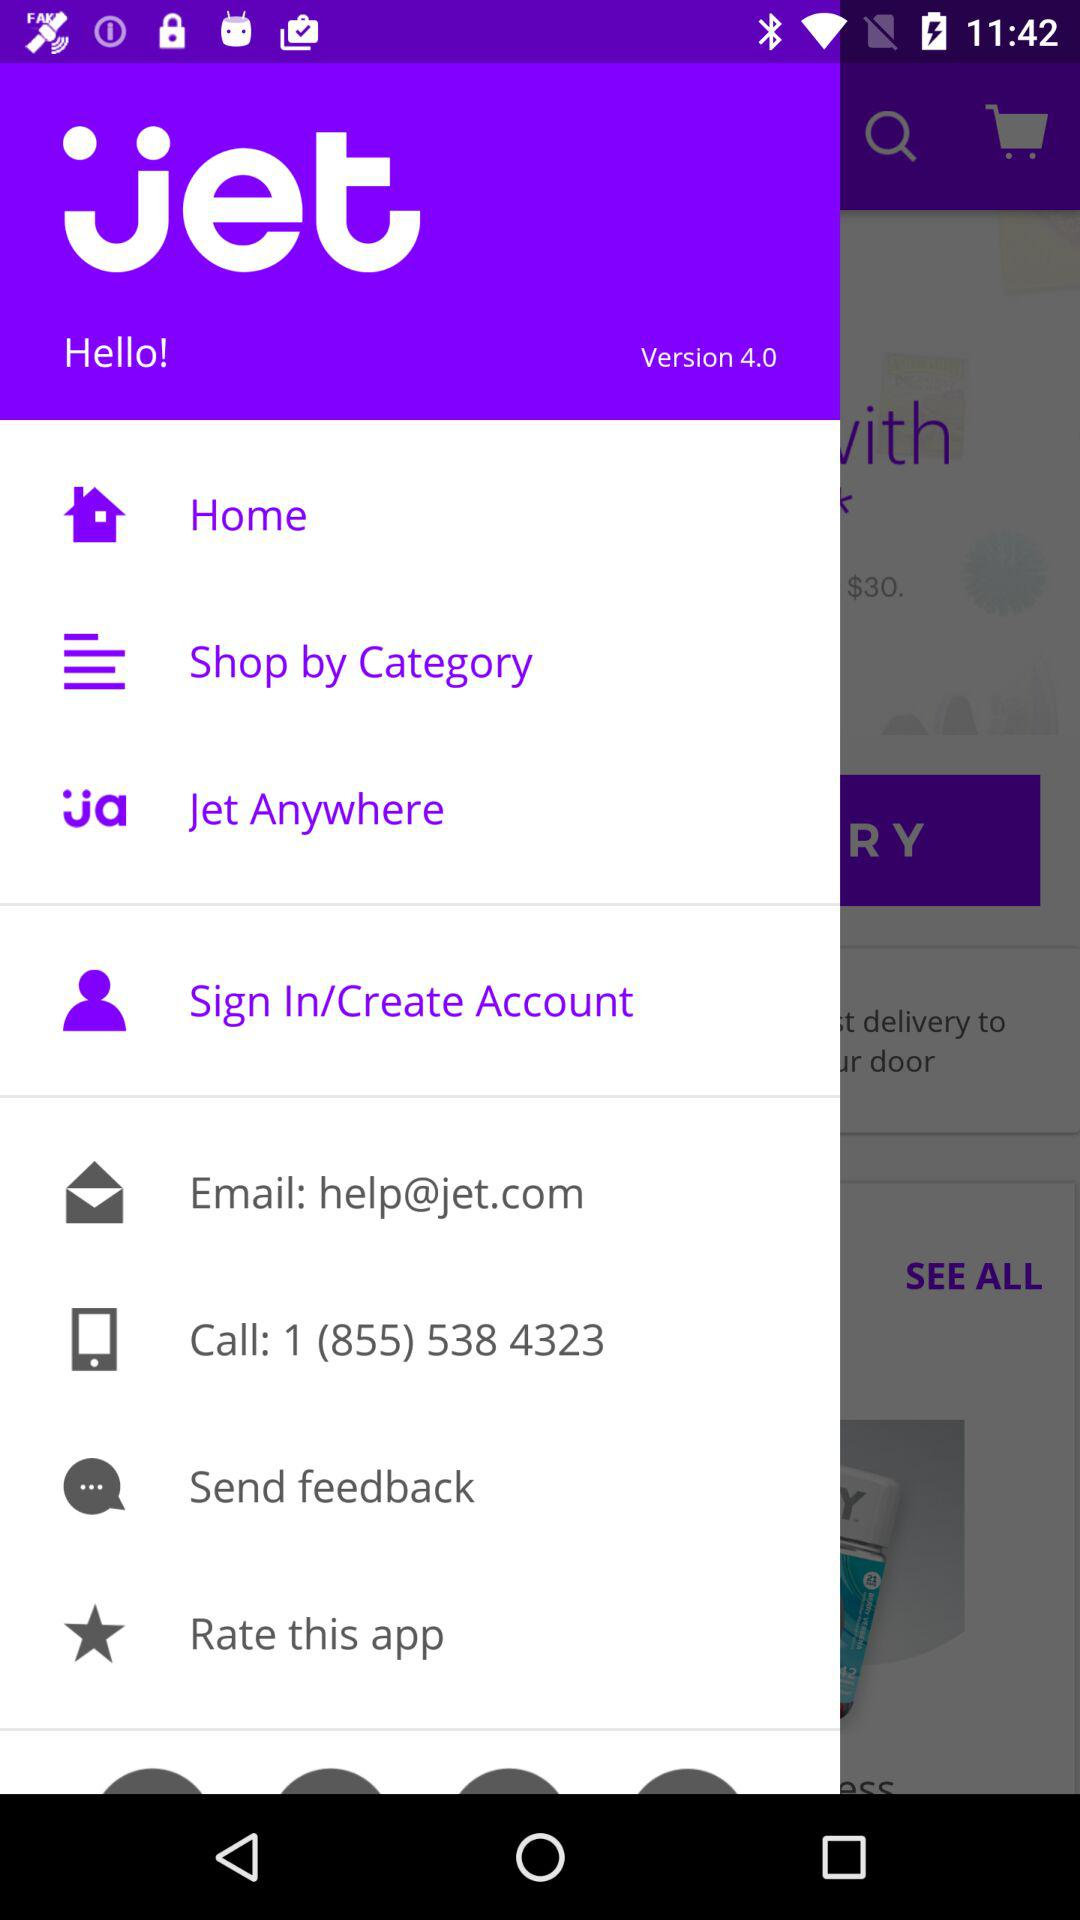What is the email address? The email address is help@jet.com. 